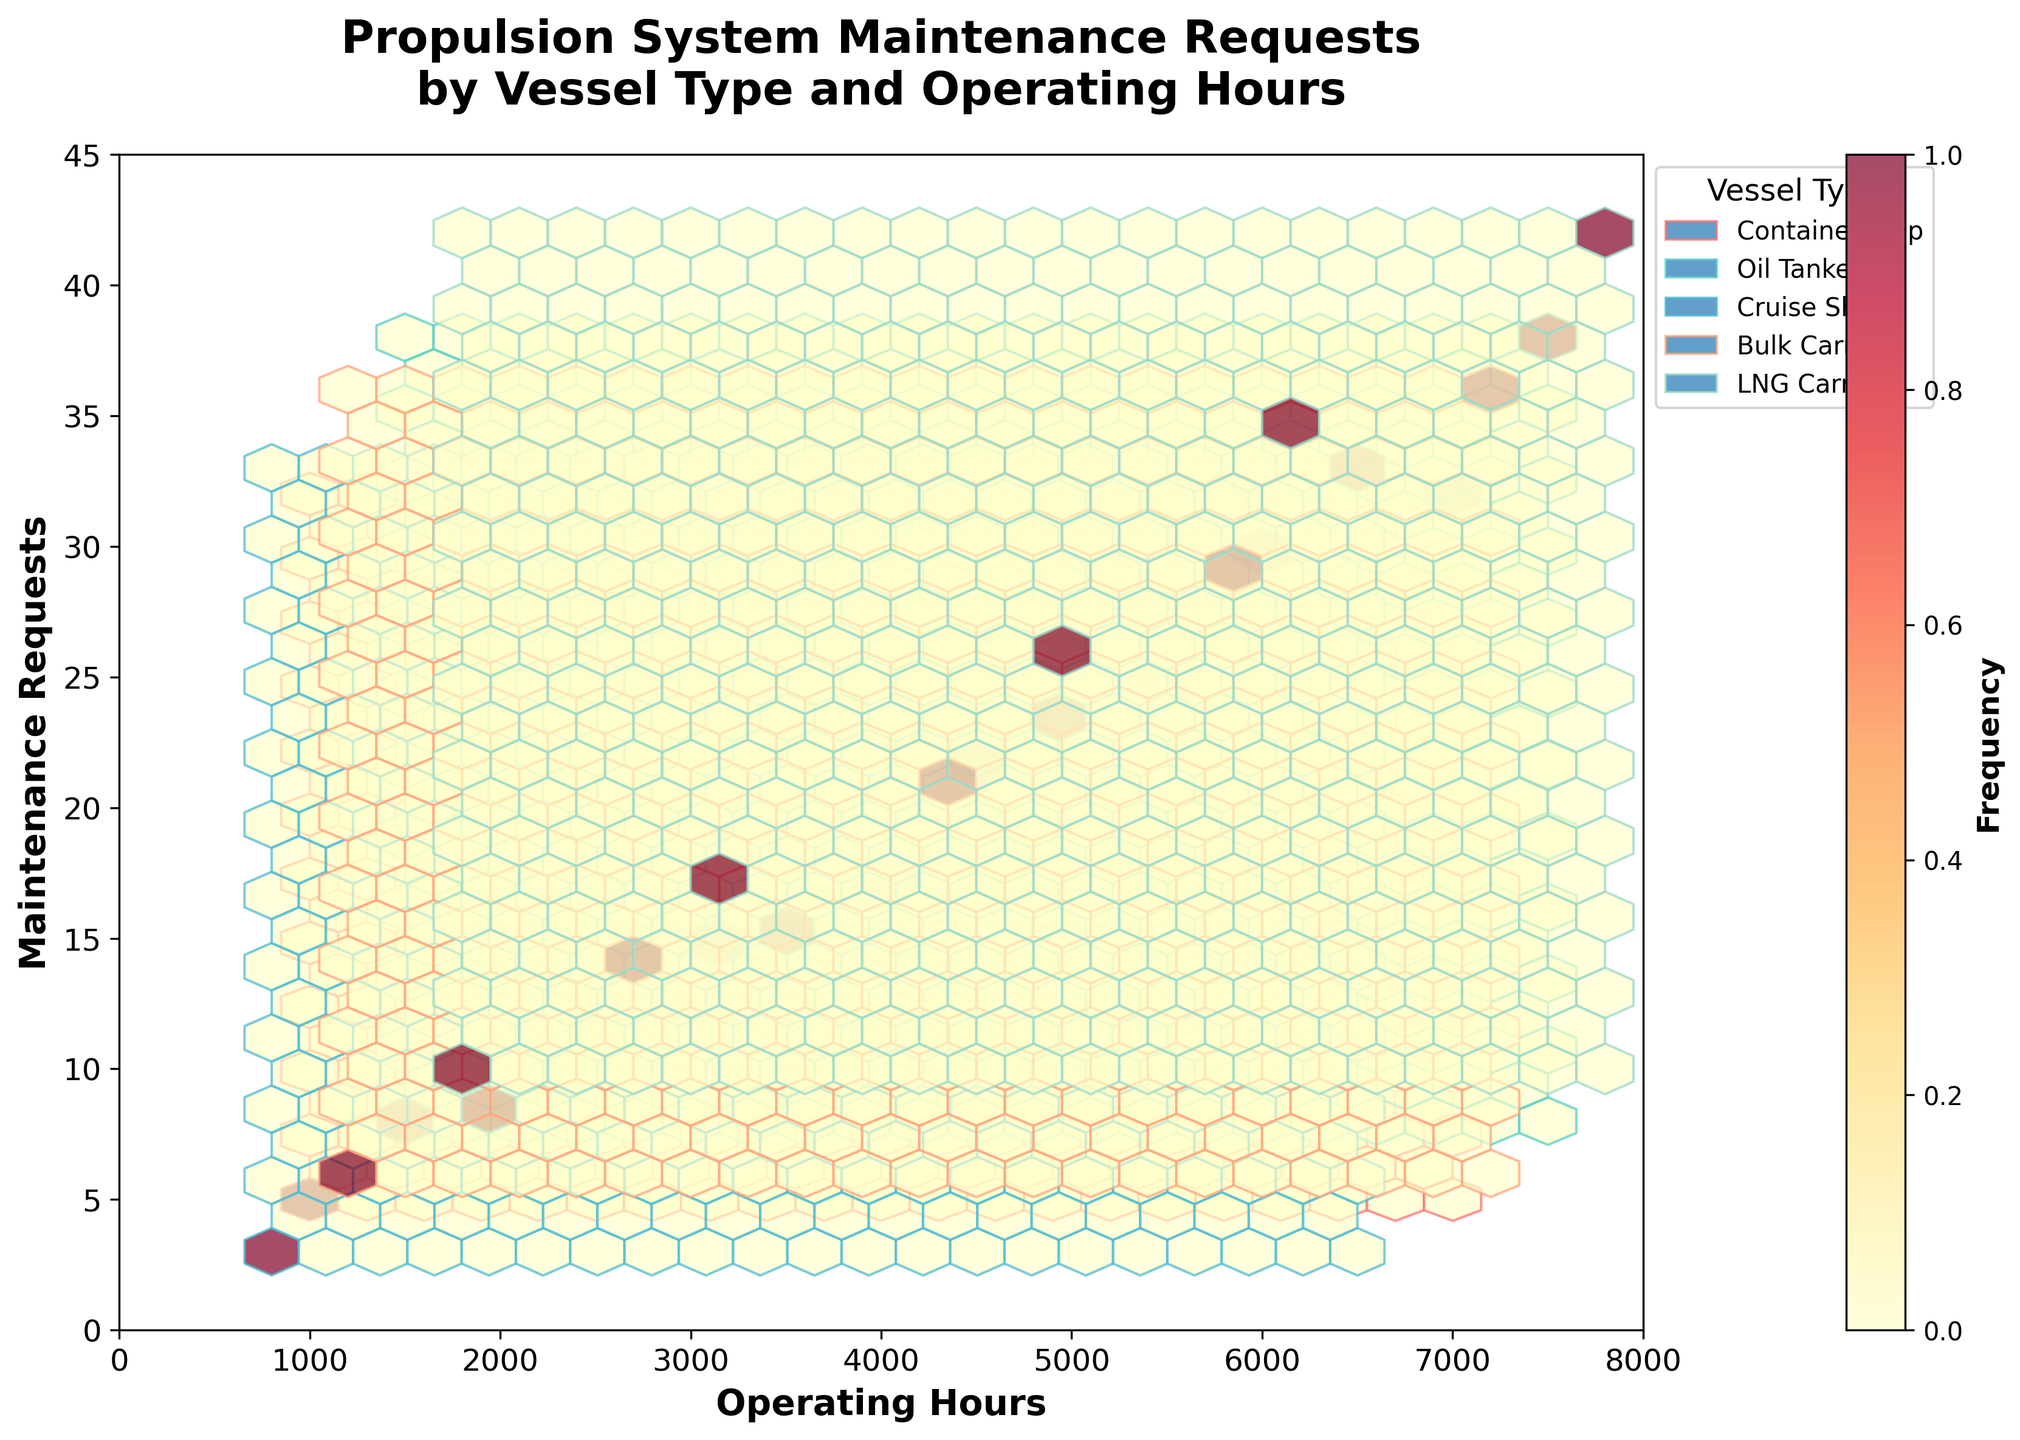What is the title of the plot? The title is located at the top of the plot. It usually gives a brief description of what the plot is about.
Answer: "Propulsion System Maintenance Requests by Vessel Type and Operating Hours" What do the x-axis and y-axis represent? The x-axis is labeled "Operating Hours" and the y-axis is labeled "Maintenance Requests." These labels indicate what is being measured along each axis.
Answer: Operating Hours (x-axis) and Maintenance Requests (y-axis) How many vessel types are represented in the plot? By looking at different colors and the legend on the plot, we can count the distinct types of vessels listed.
Answer: 5 Which vessel type has the highest number of maintenance requests at 7500 operating hours? By locating 7500 on the x-axis and observing the corresponding hexagons, we can identify the vessel type associated with the highest number of maintenance requests.
Answer: Oil Tanker What is the color representation for the 'Container Ship' vessel type? The legend on the plot associates each vessel type with a specific color.
Answer: Red Which vessel type seems to have the highest frequency of maintenance requests across all operating hours? The 'Frequency' color bar indicates the density of hexagons. The vessel type with the densest, or darkest, group of hexagons will show the highest frequency.
Answer: LNG Carrier How do the maintenance requests for 'Oil Tanker' and 'Cruise Ship' compare at around 5000 operating hours? By observing the plot near the 5000 operating hours mark, we compare the maintenance requests indicated by the hexagons for both vessel types.
Answer: Oil Tanker > Cruise Ship What range of operating hours shows the most frequent maintenance requests for 'Bulk Carrier'? The densest, or darkest, section of hexagons for 'Bulk Carrier' would indicate the operating hours range for its frequent maintenance requests.
Answer: 4000 to 6000 hours How does the density of maintenance requests change with increasing operating hours for 'LNG Carrier'? Analyzing the plot, we observe how the coloration of hexagons changes for 'LNG Carrier' as operating hours increase, indicating changes in request frequency.
Answer: Increases with operating hours At around 3000 operating hours, which vessel type has the lowest number of maintenance requests? Locate the 3000 mark on the x-axis and identify the vessel type with the fewest or lightest hexagons.
Answer: Cruise Ship 